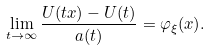<formula> <loc_0><loc_0><loc_500><loc_500>\lim _ { t \to \infty } \frac { U ( t x ) - U ( t ) } { a ( t ) } = \varphi _ { \xi } ( x ) .</formula> 